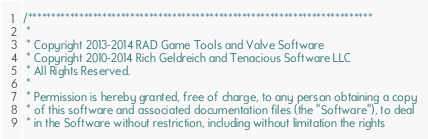<code> <loc_0><loc_0><loc_500><loc_500><_C++_>/**************************************************************************
 *
 * Copyright 2013-2014 RAD Game Tools and Valve Software
 * Copyright 2010-2014 Rich Geldreich and Tenacious Software LLC
 * All Rights Reserved.
 *
 * Permission is hereby granted, free of charge, to any person obtaining a copy
 * of this software and associated documentation files (the "Software"), to deal
 * in the Software without restriction, including without limitation the rights</code> 